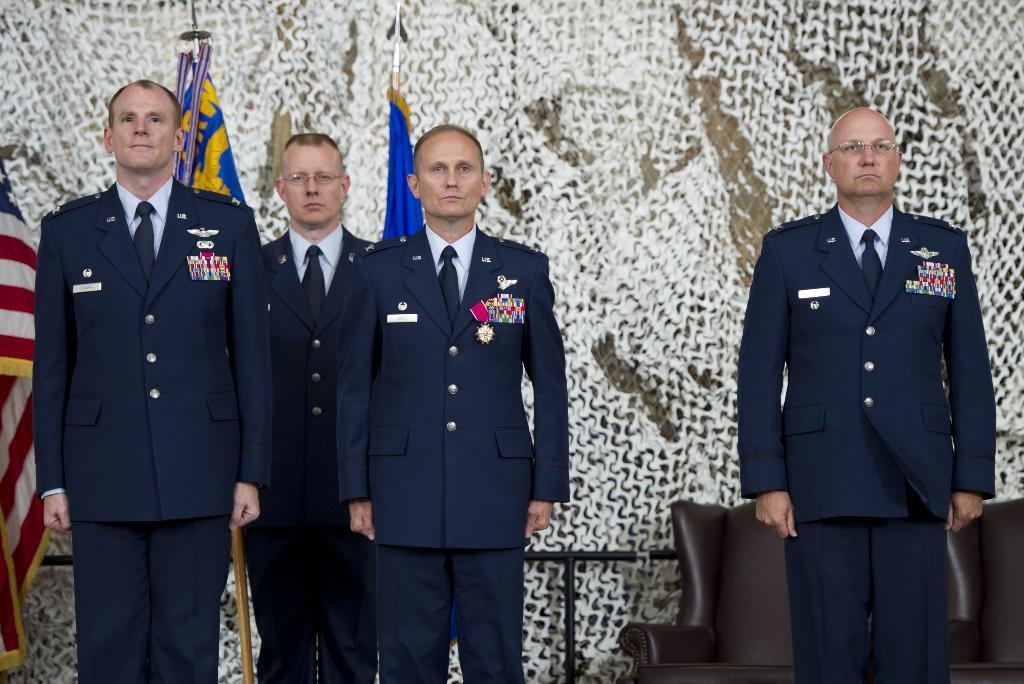How would you summarize this image in a sentence or two? In this image we can see people in costumes and we can also see chair, rods and flags. 